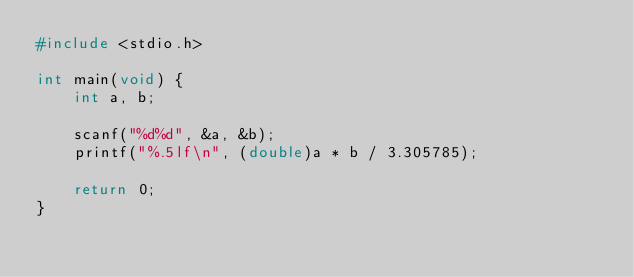<code> <loc_0><loc_0><loc_500><loc_500><_C_>#include <stdio.h>

int main(void) {
    int a, b;

    scanf("%d%d", &a, &b);
    printf("%.5lf\n", (double)a * b / 3.305785);

    return 0;
}</code> 